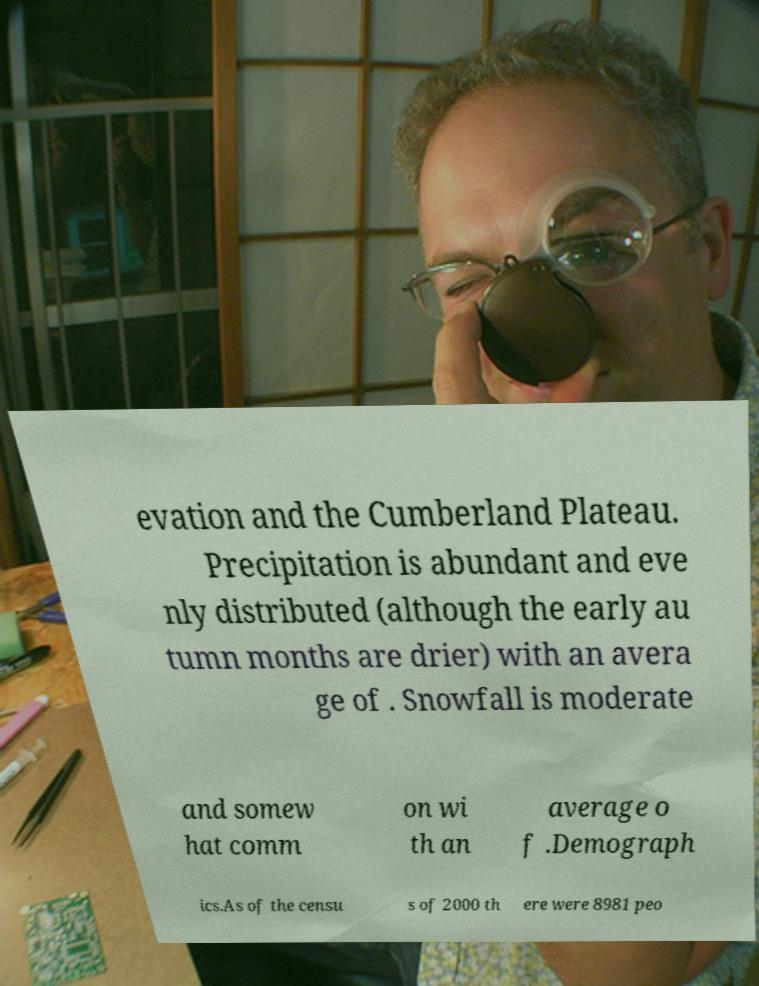There's text embedded in this image that I need extracted. Can you transcribe it verbatim? evation and the Cumberland Plateau. Precipitation is abundant and eve nly distributed (although the early au tumn months are drier) with an avera ge of . Snowfall is moderate and somew hat comm on wi th an average o f .Demograph ics.As of the censu s of 2000 th ere were 8981 peo 